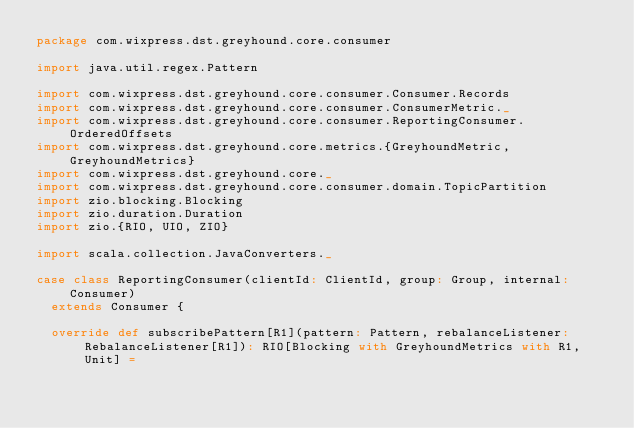Convert code to text. <code><loc_0><loc_0><loc_500><loc_500><_Scala_>package com.wixpress.dst.greyhound.core.consumer

import java.util.regex.Pattern

import com.wixpress.dst.greyhound.core.consumer.Consumer.Records
import com.wixpress.dst.greyhound.core.consumer.ConsumerMetric._
import com.wixpress.dst.greyhound.core.consumer.ReportingConsumer.OrderedOffsets
import com.wixpress.dst.greyhound.core.metrics.{GreyhoundMetric, GreyhoundMetrics}
import com.wixpress.dst.greyhound.core._
import com.wixpress.dst.greyhound.core.consumer.domain.TopicPartition
import zio.blocking.Blocking
import zio.duration.Duration
import zio.{RIO, UIO, ZIO}

import scala.collection.JavaConverters._

case class ReportingConsumer(clientId: ClientId, group: Group, internal: Consumer)
  extends Consumer {

  override def subscribePattern[R1](pattern: Pattern, rebalanceListener: RebalanceListener[R1]): RIO[Blocking with GreyhoundMetrics with R1, Unit] =</code> 